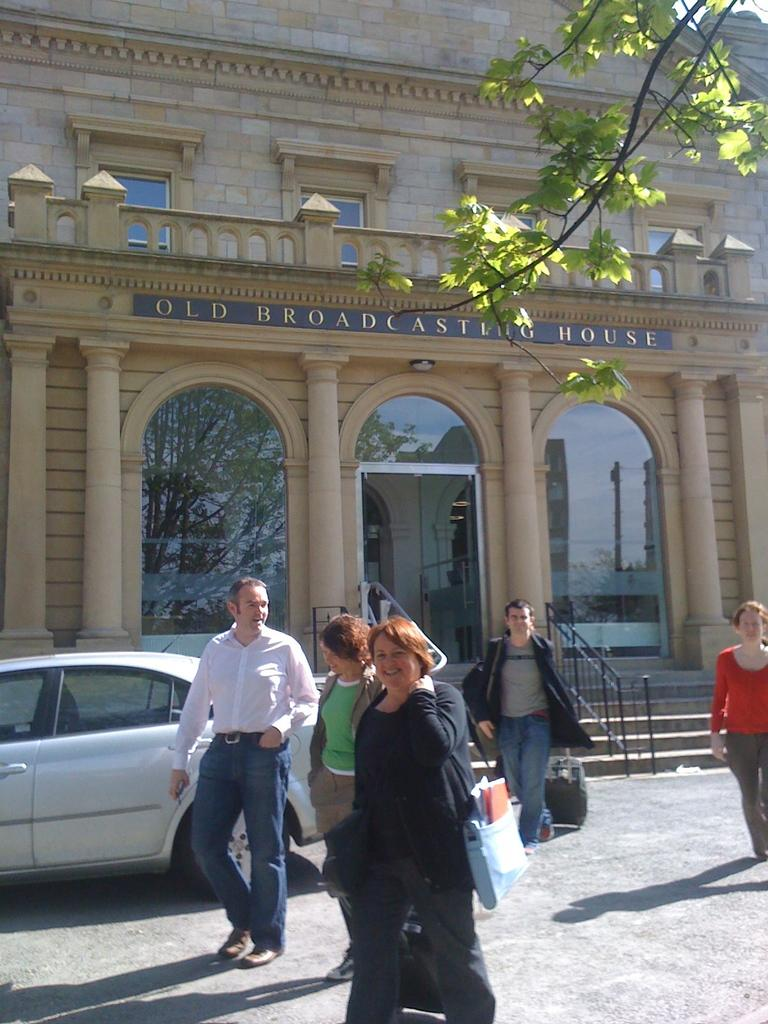What type of surface can be seen in the image? Ground is visible in the image. What else can be seen in the image besides the ground? There are people standing, a grey car, trees, stairs, railing, and a building in the image. Can you describe the building in the image? The building in the image is cream in color. What architectural feature is present in the image? There are stairs and railing in the image. What type of quartz can be seen in the image? There is no quartz present in the image. How does the nut affect the people standing in the image? There is no nut present in the image, so it cannot affect the people standing people standing in the image. 